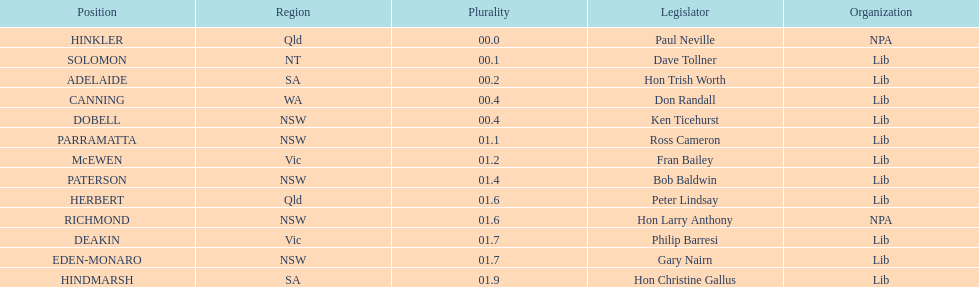How many states were represented in the seats? 6. 